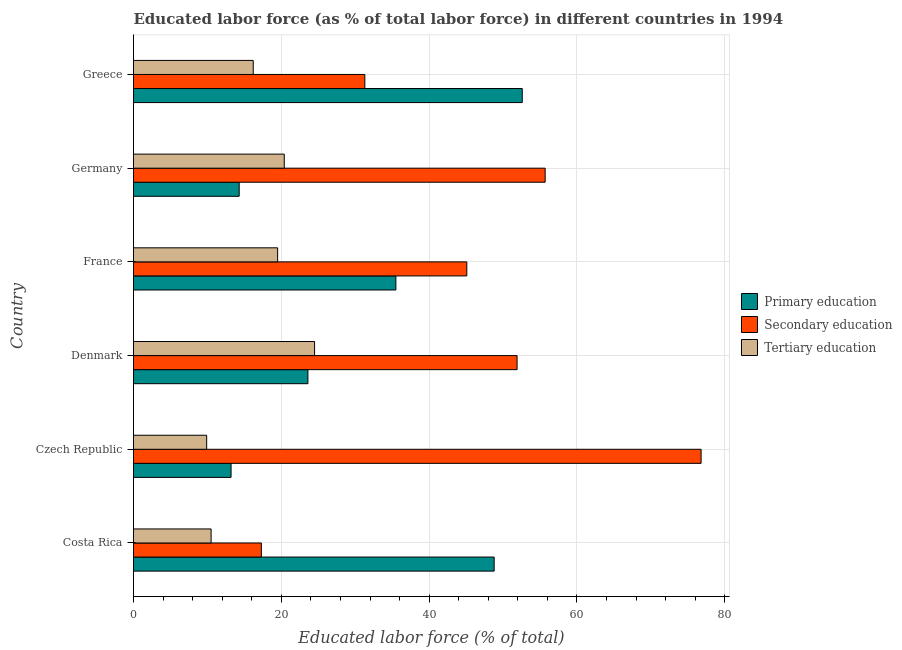How many different coloured bars are there?
Provide a short and direct response. 3. How many groups of bars are there?
Your answer should be very brief. 6. What is the label of the 5th group of bars from the top?
Keep it short and to the point. Czech Republic. What is the percentage of labor force who received secondary education in Costa Rica?
Your response must be concise. 17.3. Across all countries, what is the maximum percentage of labor force who received primary education?
Make the answer very short. 52.6. Across all countries, what is the minimum percentage of labor force who received tertiary education?
Your answer should be very brief. 9.9. In which country was the percentage of labor force who received tertiary education maximum?
Make the answer very short. Denmark. In which country was the percentage of labor force who received primary education minimum?
Offer a very short reply. Czech Republic. What is the total percentage of labor force who received secondary education in the graph?
Make the answer very short. 278.1. What is the difference between the percentage of labor force who received primary education in Costa Rica and that in Germany?
Keep it short and to the point. 34.5. What is the difference between the percentage of labor force who received secondary education in Czech Republic and the percentage of labor force who received primary education in Germany?
Keep it short and to the point. 62.5. What is the average percentage of labor force who received primary education per country?
Ensure brevity in your answer.  31.33. In how many countries, is the percentage of labor force who received tertiary education greater than 44 %?
Offer a terse response. 0. What is the ratio of the percentage of labor force who received primary education in Denmark to that in Germany?
Offer a very short reply. 1.65. Is the difference between the percentage of labor force who received tertiary education in France and Greece greater than the difference between the percentage of labor force who received primary education in France and Greece?
Your response must be concise. Yes. In how many countries, is the percentage of labor force who received secondary education greater than the average percentage of labor force who received secondary education taken over all countries?
Offer a very short reply. 3. Is the sum of the percentage of labor force who received primary education in Czech Republic and Germany greater than the maximum percentage of labor force who received secondary education across all countries?
Offer a terse response. No. What does the 2nd bar from the top in Czech Republic represents?
Provide a succinct answer. Secondary education. What does the 3rd bar from the bottom in Costa Rica represents?
Your response must be concise. Tertiary education. Is it the case that in every country, the sum of the percentage of labor force who received primary education and percentage of labor force who received secondary education is greater than the percentage of labor force who received tertiary education?
Provide a succinct answer. Yes. How many bars are there?
Make the answer very short. 18. Are all the bars in the graph horizontal?
Offer a very short reply. Yes. How many countries are there in the graph?
Provide a short and direct response. 6. Are the values on the major ticks of X-axis written in scientific E-notation?
Your answer should be compact. No. Does the graph contain grids?
Your answer should be compact. Yes. Where does the legend appear in the graph?
Give a very brief answer. Center right. How are the legend labels stacked?
Keep it short and to the point. Vertical. What is the title of the graph?
Keep it short and to the point. Educated labor force (as % of total labor force) in different countries in 1994. What is the label or title of the X-axis?
Offer a terse response. Educated labor force (% of total). What is the Educated labor force (% of total) of Primary education in Costa Rica?
Offer a terse response. 48.8. What is the Educated labor force (% of total) of Secondary education in Costa Rica?
Offer a terse response. 17.3. What is the Educated labor force (% of total) of Primary education in Czech Republic?
Your answer should be compact. 13.2. What is the Educated labor force (% of total) of Secondary education in Czech Republic?
Give a very brief answer. 76.8. What is the Educated labor force (% of total) in Tertiary education in Czech Republic?
Provide a short and direct response. 9.9. What is the Educated labor force (% of total) in Primary education in Denmark?
Provide a short and direct response. 23.6. What is the Educated labor force (% of total) in Secondary education in Denmark?
Make the answer very short. 51.9. What is the Educated labor force (% of total) in Tertiary education in Denmark?
Make the answer very short. 24.5. What is the Educated labor force (% of total) in Primary education in France?
Offer a very short reply. 35.5. What is the Educated labor force (% of total) in Secondary education in France?
Your response must be concise. 45.1. What is the Educated labor force (% of total) in Tertiary education in France?
Give a very brief answer. 19.5. What is the Educated labor force (% of total) in Primary education in Germany?
Your response must be concise. 14.3. What is the Educated labor force (% of total) in Secondary education in Germany?
Your response must be concise. 55.7. What is the Educated labor force (% of total) in Tertiary education in Germany?
Your response must be concise. 20.4. What is the Educated labor force (% of total) in Primary education in Greece?
Offer a very short reply. 52.6. What is the Educated labor force (% of total) in Secondary education in Greece?
Offer a very short reply. 31.3. What is the Educated labor force (% of total) of Tertiary education in Greece?
Provide a succinct answer. 16.2. Across all countries, what is the maximum Educated labor force (% of total) in Primary education?
Your response must be concise. 52.6. Across all countries, what is the maximum Educated labor force (% of total) in Secondary education?
Provide a succinct answer. 76.8. Across all countries, what is the maximum Educated labor force (% of total) in Tertiary education?
Your answer should be compact. 24.5. Across all countries, what is the minimum Educated labor force (% of total) of Primary education?
Make the answer very short. 13.2. Across all countries, what is the minimum Educated labor force (% of total) of Secondary education?
Your response must be concise. 17.3. Across all countries, what is the minimum Educated labor force (% of total) in Tertiary education?
Make the answer very short. 9.9. What is the total Educated labor force (% of total) in Primary education in the graph?
Give a very brief answer. 188. What is the total Educated labor force (% of total) of Secondary education in the graph?
Ensure brevity in your answer.  278.1. What is the total Educated labor force (% of total) of Tertiary education in the graph?
Provide a succinct answer. 101. What is the difference between the Educated labor force (% of total) in Primary education in Costa Rica and that in Czech Republic?
Offer a terse response. 35.6. What is the difference between the Educated labor force (% of total) of Secondary education in Costa Rica and that in Czech Republic?
Keep it short and to the point. -59.5. What is the difference between the Educated labor force (% of total) in Primary education in Costa Rica and that in Denmark?
Offer a very short reply. 25.2. What is the difference between the Educated labor force (% of total) of Secondary education in Costa Rica and that in Denmark?
Ensure brevity in your answer.  -34.6. What is the difference between the Educated labor force (% of total) of Tertiary education in Costa Rica and that in Denmark?
Provide a short and direct response. -14. What is the difference between the Educated labor force (% of total) in Primary education in Costa Rica and that in France?
Your answer should be very brief. 13.3. What is the difference between the Educated labor force (% of total) of Secondary education in Costa Rica and that in France?
Ensure brevity in your answer.  -27.8. What is the difference between the Educated labor force (% of total) of Primary education in Costa Rica and that in Germany?
Keep it short and to the point. 34.5. What is the difference between the Educated labor force (% of total) of Secondary education in Costa Rica and that in Germany?
Provide a succinct answer. -38.4. What is the difference between the Educated labor force (% of total) in Secondary education in Costa Rica and that in Greece?
Provide a succinct answer. -14. What is the difference between the Educated labor force (% of total) in Tertiary education in Costa Rica and that in Greece?
Ensure brevity in your answer.  -5.7. What is the difference between the Educated labor force (% of total) in Primary education in Czech Republic and that in Denmark?
Give a very brief answer. -10.4. What is the difference between the Educated labor force (% of total) of Secondary education in Czech Republic and that in Denmark?
Offer a terse response. 24.9. What is the difference between the Educated labor force (% of total) of Tertiary education in Czech Republic and that in Denmark?
Provide a succinct answer. -14.6. What is the difference between the Educated labor force (% of total) in Primary education in Czech Republic and that in France?
Your answer should be compact. -22.3. What is the difference between the Educated labor force (% of total) of Secondary education in Czech Republic and that in France?
Offer a terse response. 31.7. What is the difference between the Educated labor force (% of total) in Tertiary education in Czech Republic and that in France?
Make the answer very short. -9.6. What is the difference between the Educated labor force (% of total) in Primary education in Czech Republic and that in Germany?
Provide a succinct answer. -1.1. What is the difference between the Educated labor force (% of total) in Secondary education in Czech Republic and that in Germany?
Make the answer very short. 21.1. What is the difference between the Educated labor force (% of total) in Primary education in Czech Republic and that in Greece?
Offer a terse response. -39.4. What is the difference between the Educated labor force (% of total) of Secondary education in Czech Republic and that in Greece?
Offer a terse response. 45.5. What is the difference between the Educated labor force (% of total) of Tertiary education in Czech Republic and that in Greece?
Give a very brief answer. -6.3. What is the difference between the Educated labor force (% of total) of Tertiary education in Denmark and that in France?
Your answer should be compact. 5. What is the difference between the Educated labor force (% of total) of Primary education in Denmark and that in Germany?
Ensure brevity in your answer.  9.3. What is the difference between the Educated labor force (% of total) in Primary education in Denmark and that in Greece?
Offer a very short reply. -29. What is the difference between the Educated labor force (% of total) of Secondary education in Denmark and that in Greece?
Your response must be concise. 20.6. What is the difference between the Educated labor force (% of total) in Tertiary education in Denmark and that in Greece?
Offer a very short reply. 8.3. What is the difference between the Educated labor force (% of total) of Primary education in France and that in Germany?
Keep it short and to the point. 21.2. What is the difference between the Educated labor force (% of total) of Secondary education in France and that in Germany?
Your response must be concise. -10.6. What is the difference between the Educated labor force (% of total) in Primary education in France and that in Greece?
Offer a very short reply. -17.1. What is the difference between the Educated labor force (% of total) of Secondary education in France and that in Greece?
Make the answer very short. 13.8. What is the difference between the Educated labor force (% of total) in Primary education in Germany and that in Greece?
Provide a succinct answer. -38.3. What is the difference between the Educated labor force (% of total) of Secondary education in Germany and that in Greece?
Offer a very short reply. 24.4. What is the difference between the Educated labor force (% of total) in Tertiary education in Germany and that in Greece?
Your answer should be very brief. 4.2. What is the difference between the Educated labor force (% of total) of Primary education in Costa Rica and the Educated labor force (% of total) of Tertiary education in Czech Republic?
Offer a terse response. 38.9. What is the difference between the Educated labor force (% of total) in Primary education in Costa Rica and the Educated labor force (% of total) in Tertiary education in Denmark?
Make the answer very short. 24.3. What is the difference between the Educated labor force (% of total) in Primary education in Costa Rica and the Educated labor force (% of total) in Secondary education in France?
Keep it short and to the point. 3.7. What is the difference between the Educated labor force (% of total) of Primary education in Costa Rica and the Educated labor force (% of total) of Tertiary education in France?
Ensure brevity in your answer.  29.3. What is the difference between the Educated labor force (% of total) of Secondary education in Costa Rica and the Educated labor force (% of total) of Tertiary education in France?
Provide a short and direct response. -2.2. What is the difference between the Educated labor force (% of total) of Primary education in Costa Rica and the Educated labor force (% of total) of Secondary education in Germany?
Offer a terse response. -6.9. What is the difference between the Educated labor force (% of total) of Primary education in Costa Rica and the Educated labor force (% of total) of Tertiary education in Germany?
Offer a very short reply. 28.4. What is the difference between the Educated labor force (% of total) of Secondary education in Costa Rica and the Educated labor force (% of total) of Tertiary education in Germany?
Provide a short and direct response. -3.1. What is the difference between the Educated labor force (% of total) in Primary education in Costa Rica and the Educated labor force (% of total) in Secondary education in Greece?
Your answer should be very brief. 17.5. What is the difference between the Educated labor force (% of total) of Primary education in Costa Rica and the Educated labor force (% of total) of Tertiary education in Greece?
Your answer should be compact. 32.6. What is the difference between the Educated labor force (% of total) in Primary education in Czech Republic and the Educated labor force (% of total) in Secondary education in Denmark?
Keep it short and to the point. -38.7. What is the difference between the Educated labor force (% of total) in Secondary education in Czech Republic and the Educated labor force (% of total) in Tertiary education in Denmark?
Offer a very short reply. 52.3. What is the difference between the Educated labor force (% of total) of Primary education in Czech Republic and the Educated labor force (% of total) of Secondary education in France?
Provide a short and direct response. -31.9. What is the difference between the Educated labor force (% of total) of Primary education in Czech Republic and the Educated labor force (% of total) of Tertiary education in France?
Offer a very short reply. -6.3. What is the difference between the Educated labor force (% of total) in Secondary education in Czech Republic and the Educated labor force (% of total) in Tertiary education in France?
Provide a succinct answer. 57.3. What is the difference between the Educated labor force (% of total) in Primary education in Czech Republic and the Educated labor force (% of total) in Secondary education in Germany?
Keep it short and to the point. -42.5. What is the difference between the Educated labor force (% of total) in Primary education in Czech Republic and the Educated labor force (% of total) in Tertiary education in Germany?
Your answer should be very brief. -7.2. What is the difference between the Educated labor force (% of total) in Secondary education in Czech Republic and the Educated labor force (% of total) in Tertiary education in Germany?
Provide a succinct answer. 56.4. What is the difference between the Educated labor force (% of total) in Primary education in Czech Republic and the Educated labor force (% of total) in Secondary education in Greece?
Your answer should be compact. -18.1. What is the difference between the Educated labor force (% of total) in Primary education in Czech Republic and the Educated labor force (% of total) in Tertiary education in Greece?
Provide a short and direct response. -3. What is the difference between the Educated labor force (% of total) of Secondary education in Czech Republic and the Educated labor force (% of total) of Tertiary education in Greece?
Your answer should be very brief. 60.6. What is the difference between the Educated labor force (% of total) of Primary education in Denmark and the Educated labor force (% of total) of Secondary education in France?
Ensure brevity in your answer.  -21.5. What is the difference between the Educated labor force (% of total) of Secondary education in Denmark and the Educated labor force (% of total) of Tertiary education in France?
Offer a terse response. 32.4. What is the difference between the Educated labor force (% of total) of Primary education in Denmark and the Educated labor force (% of total) of Secondary education in Germany?
Make the answer very short. -32.1. What is the difference between the Educated labor force (% of total) in Primary education in Denmark and the Educated labor force (% of total) in Tertiary education in Germany?
Your answer should be very brief. 3.2. What is the difference between the Educated labor force (% of total) of Secondary education in Denmark and the Educated labor force (% of total) of Tertiary education in Germany?
Your answer should be compact. 31.5. What is the difference between the Educated labor force (% of total) of Primary education in Denmark and the Educated labor force (% of total) of Secondary education in Greece?
Give a very brief answer. -7.7. What is the difference between the Educated labor force (% of total) in Primary education in Denmark and the Educated labor force (% of total) in Tertiary education in Greece?
Your answer should be compact. 7.4. What is the difference between the Educated labor force (% of total) in Secondary education in Denmark and the Educated labor force (% of total) in Tertiary education in Greece?
Ensure brevity in your answer.  35.7. What is the difference between the Educated labor force (% of total) in Primary education in France and the Educated labor force (% of total) in Secondary education in Germany?
Offer a terse response. -20.2. What is the difference between the Educated labor force (% of total) of Secondary education in France and the Educated labor force (% of total) of Tertiary education in Germany?
Make the answer very short. 24.7. What is the difference between the Educated labor force (% of total) in Primary education in France and the Educated labor force (% of total) in Secondary education in Greece?
Ensure brevity in your answer.  4.2. What is the difference between the Educated labor force (% of total) in Primary education in France and the Educated labor force (% of total) in Tertiary education in Greece?
Your answer should be compact. 19.3. What is the difference between the Educated labor force (% of total) in Secondary education in France and the Educated labor force (% of total) in Tertiary education in Greece?
Offer a very short reply. 28.9. What is the difference between the Educated labor force (% of total) of Secondary education in Germany and the Educated labor force (% of total) of Tertiary education in Greece?
Provide a short and direct response. 39.5. What is the average Educated labor force (% of total) of Primary education per country?
Give a very brief answer. 31.33. What is the average Educated labor force (% of total) of Secondary education per country?
Your answer should be very brief. 46.35. What is the average Educated labor force (% of total) of Tertiary education per country?
Offer a terse response. 16.83. What is the difference between the Educated labor force (% of total) of Primary education and Educated labor force (% of total) of Secondary education in Costa Rica?
Provide a succinct answer. 31.5. What is the difference between the Educated labor force (% of total) in Primary education and Educated labor force (% of total) in Tertiary education in Costa Rica?
Ensure brevity in your answer.  38.3. What is the difference between the Educated labor force (% of total) in Primary education and Educated labor force (% of total) in Secondary education in Czech Republic?
Keep it short and to the point. -63.6. What is the difference between the Educated labor force (% of total) in Secondary education and Educated labor force (% of total) in Tertiary education in Czech Republic?
Ensure brevity in your answer.  66.9. What is the difference between the Educated labor force (% of total) in Primary education and Educated labor force (% of total) in Secondary education in Denmark?
Offer a terse response. -28.3. What is the difference between the Educated labor force (% of total) of Secondary education and Educated labor force (% of total) of Tertiary education in Denmark?
Ensure brevity in your answer.  27.4. What is the difference between the Educated labor force (% of total) of Secondary education and Educated labor force (% of total) of Tertiary education in France?
Provide a short and direct response. 25.6. What is the difference between the Educated labor force (% of total) in Primary education and Educated labor force (% of total) in Secondary education in Germany?
Make the answer very short. -41.4. What is the difference between the Educated labor force (% of total) of Secondary education and Educated labor force (% of total) of Tertiary education in Germany?
Your response must be concise. 35.3. What is the difference between the Educated labor force (% of total) in Primary education and Educated labor force (% of total) in Secondary education in Greece?
Offer a terse response. 21.3. What is the difference between the Educated labor force (% of total) in Primary education and Educated labor force (% of total) in Tertiary education in Greece?
Make the answer very short. 36.4. What is the difference between the Educated labor force (% of total) of Secondary education and Educated labor force (% of total) of Tertiary education in Greece?
Make the answer very short. 15.1. What is the ratio of the Educated labor force (% of total) in Primary education in Costa Rica to that in Czech Republic?
Give a very brief answer. 3.7. What is the ratio of the Educated labor force (% of total) in Secondary education in Costa Rica to that in Czech Republic?
Offer a terse response. 0.23. What is the ratio of the Educated labor force (% of total) in Tertiary education in Costa Rica to that in Czech Republic?
Provide a succinct answer. 1.06. What is the ratio of the Educated labor force (% of total) in Primary education in Costa Rica to that in Denmark?
Provide a short and direct response. 2.07. What is the ratio of the Educated labor force (% of total) of Tertiary education in Costa Rica to that in Denmark?
Your response must be concise. 0.43. What is the ratio of the Educated labor force (% of total) in Primary education in Costa Rica to that in France?
Offer a very short reply. 1.37. What is the ratio of the Educated labor force (% of total) of Secondary education in Costa Rica to that in France?
Provide a succinct answer. 0.38. What is the ratio of the Educated labor force (% of total) in Tertiary education in Costa Rica to that in France?
Provide a short and direct response. 0.54. What is the ratio of the Educated labor force (% of total) in Primary education in Costa Rica to that in Germany?
Provide a succinct answer. 3.41. What is the ratio of the Educated labor force (% of total) of Secondary education in Costa Rica to that in Germany?
Your answer should be very brief. 0.31. What is the ratio of the Educated labor force (% of total) in Tertiary education in Costa Rica to that in Germany?
Make the answer very short. 0.51. What is the ratio of the Educated labor force (% of total) in Primary education in Costa Rica to that in Greece?
Keep it short and to the point. 0.93. What is the ratio of the Educated labor force (% of total) of Secondary education in Costa Rica to that in Greece?
Your answer should be compact. 0.55. What is the ratio of the Educated labor force (% of total) in Tertiary education in Costa Rica to that in Greece?
Keep it short and to the point. 0.65. What is the ratio of the Educated labor force (% of total) of Primary education in Czech Republic to that in Denmark?
Your answer should be compact. 0.56. What is the ratio of the Educated labor force (% of total) of Secondary education in Czech Republic to that in Denmark?
Give a very brief answer. 1.48. What is the ratio of the Educated labor force (% of total) of Tertiary education in Czech Republic to that in Denmark?
Ensure brevity in your answer.  0.4. What is the ratio of the Educated labor force (% of total) in Primary education in Czech Republic to that in France?
Provide a succinct answer. 0.37. What is the ratio of the Educated labor force (% of total) in Secondary education in Czech Republic to that in France?
Ensure brevity in your answer.  1.7. What is the ratio of the Educated labor force (% of total) of Tertiary education in Czech Republic to that in France?
Your response must be concise. 0.51. What is the ratio of the Educated labor force (% of total) of Primary education in Czech Republic to that in Germany?
Give a very brief answer. 0.92. What is the ratio of the Educated labor force (% of total) in Secondary education in Czech Republic to that in Germany?
Your answer should be compact. 1.38. What is the ratio of the Educated labor force (% of total) of Tertiary education in Czech Republic to that in Germany?
Provide a short and direct response. 0.49. What is the ratio of the Educated labor force (% of total) in Primary education in Czech Republic to that in Greece?
Offer a terse response. 0.25. What is the ratio of the Educated labor force (% of total) of Secondary education in Czech Republic to that in Greece?
Make the answer very short. 2.45. What is the ratio of the Educated labor force (% of total) of Tertiary education in Czech Republic to that in Greece?
Provide a succinct answer. 0.61. What is the ratio of the Educated labor force (% of total) in Primary education in Denmark to that in France?
Your answer should be compact. 0.66. What is the ratio of the Educated labor force (% of total) in Secondary education in Denmark to that in France?
Keep it short and to the point. 1.15. What is the ratio of the Educated labor force (% of total) of Tertiary education in Denmark to that in France?
Give a very brief answer. 1.26. What is the ratio of the Educated labor force (% of total) in Primary education in Denmark to that in Germany?
Your answer should be compact. 1.65. What is the ratio of the Educated labor force (% of total) of Secondary education in Denmark to that in Germany?
Your answer should be very brief. 0.93. What is the ratio of the Educated labor force (% of total) of Tertiary education in Denmark to that in Germany?
Offer a terse response. 1.2. What is the ratio of the Educated labor force (% of total) in Primary education in Denmark to that in Greece?
Keep it short and to the point. 0.45. What is the ratio of the Educated labor force (% of total) in Secondary education in Denmark to that in Greece?
Your response must be concise. 1.66. What is the ratio of the Educated labor force (% of total) in Tertiary education in Denmark to that in Greece?
Your response must be concise. 1.51. What is the ratio of the Educated labor force (% of total) in Primary education in France to that in Germany?
Provide a short and direct response. 2.48. What is the ratio of the Educated labor force (% of total) in Secondary education in France to that in Germany?
Keep it short and to the point. 0.81. What is the ratio of the Educated labor force (% of total) in Tertiary education in France to that in Germany?
Ensure brevity in your answer.  0.96. What is the ratio of the Educated labor force (% of total) in Primary education in France to that in Greece?
Your answer should be very brief. 0.67. What is the ratio of the Educated labor force (% of total) in Secondary education in France to that in Greece?
Your answer should be compact. 1.44. What is the ratio of the Educated labor force (% of total) in Tertiary education in France to that in Greece?
Make the answer very short. 1.2. What is the ratio of the Educated labor force (% of total) in Primary education in Germany to that in Greece?
Keep it short and to the point. 0.27. What is the ratio of the Educated labor force (% of total) of Secondary education in Germany to that in Greece?
Provide a short and direct response. 1.78. What is the ratio of the Educated labor force (% of total) of Tertiary education in Germany to that in Greece?
Provide a short and direct response. 1.26. What is the difference between the highest and the second highest Educated labor force (% of total) in Secondary education?
Give a very brief answer. 21.1. What is the difference between the highest and the lowest Educated labor force (% of total) of Primary education?
Give a very brief answer. 39.4. What is the difference between the highest and the lowest Educated labor force (% of total) in Secondary education?
Offer a very short reply. 59.5. 